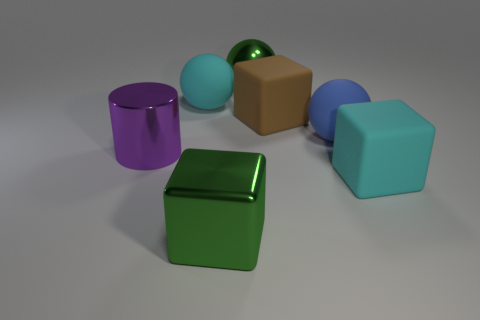What is the shape of the big cyan object that is to the right of the green object on the left side of the metallic sphere that is behind the purple metal cylinder? cube 